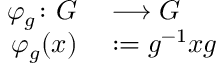Convert formula to latex. <formula><loc_0><loc_0><loc_500><loc_500>\begin{array} { r l } { \varphi _ { g } \colon G } & \longrightarrow G } \\ { \varphi _ { g } ( x ) } & \colon = g ^ { - 1 } x g } \end{array}</formula> 